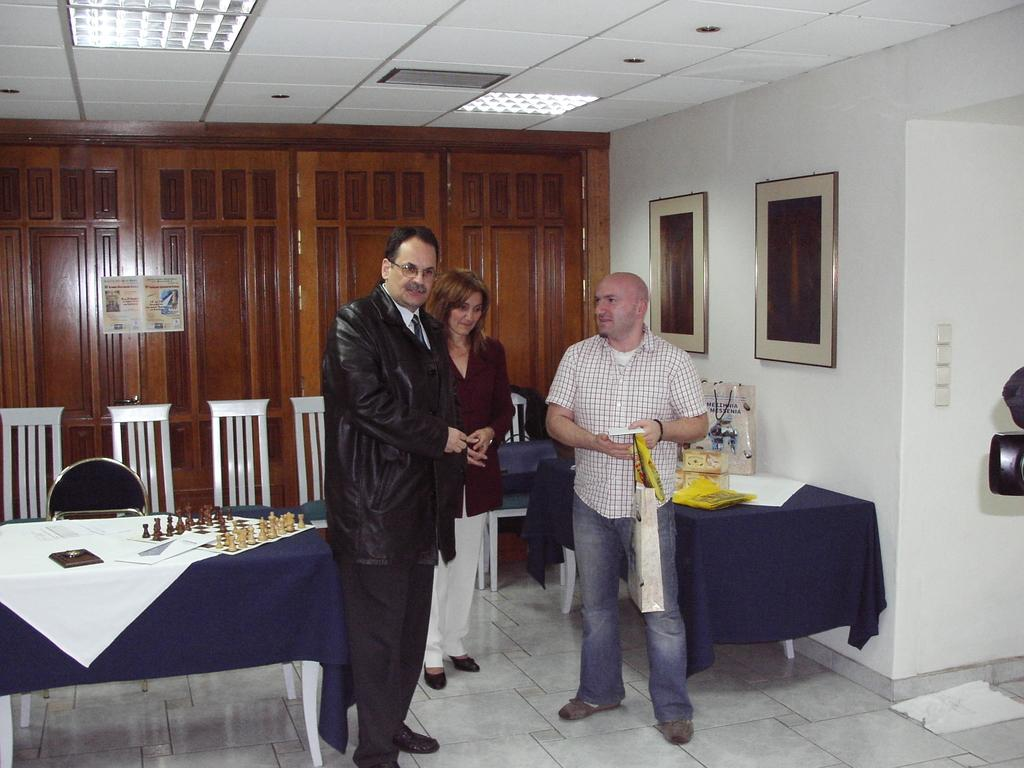What is the color of the wall in the image? The wall in the image is white. What objects are hanging on the wall? There are two photo frames hanging on the wall in the image. What type of furniture is present in the image? There are chairs and tables in the image. How many people are standing in the image? There are three people standing in the image. What is placed on the table in the image? There is a paper and a chess board on the table in the image. What type of vase is on the table in the image? There is no vase present on the table in the image. What does the mom say to the children in the image? There is no mention of a mom or any dialogue in the image. 